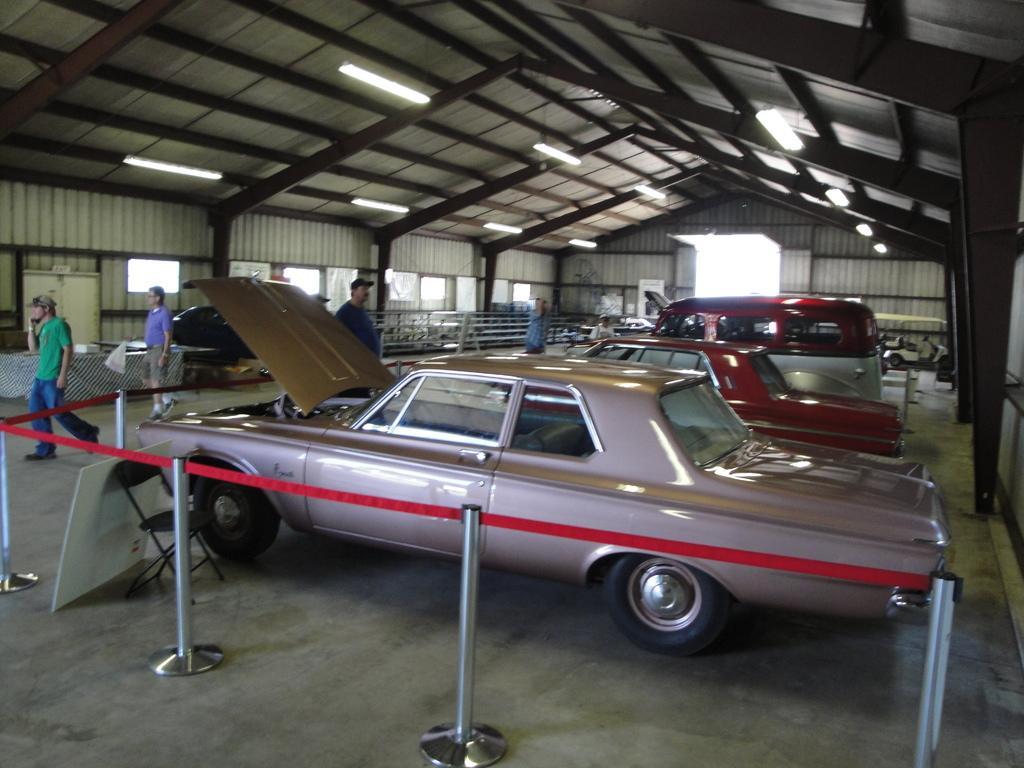In one or two sentences, can you explain what this image depicts? In this image few vehicles are on the floor. Bottom of the image there is a fence. Behind there is a chair. A board is kept near the chair. Left side two people are walking on the floor. Behind the vehicle, there is a person. Top of the image few lights are attached to the roof. Few people are on the floor. 